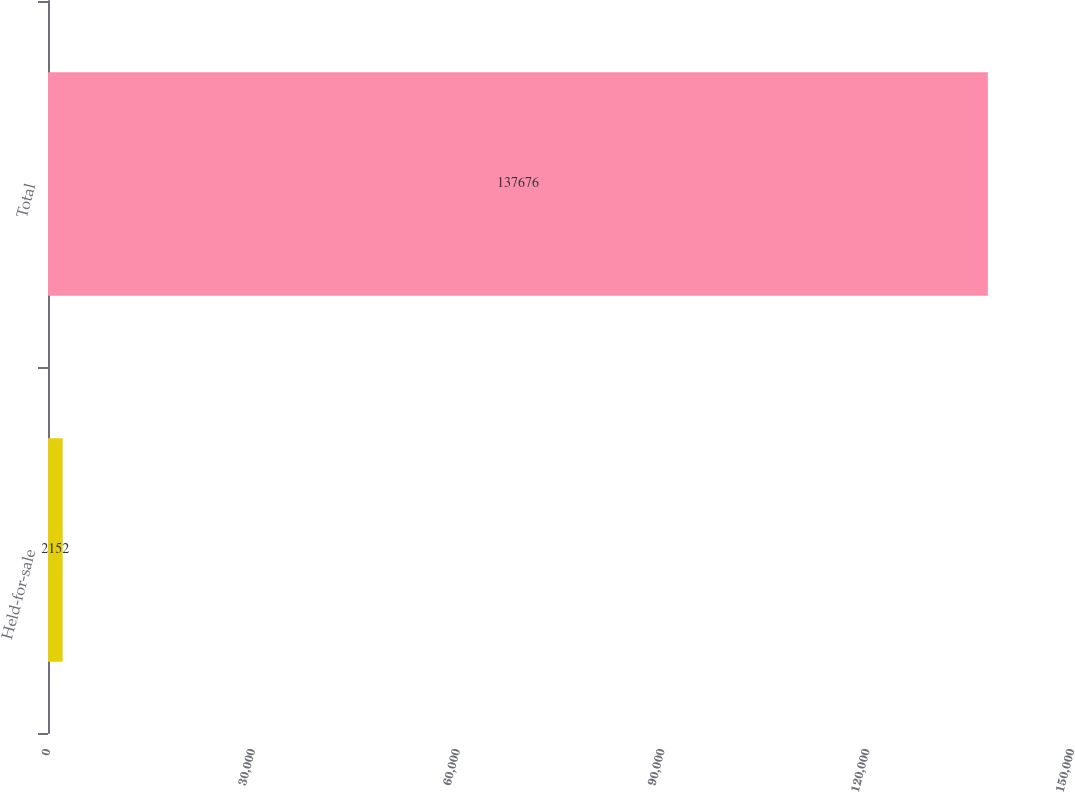Convert chart to OTSL. <chart><loc_0><loc_0><loc_500><loc_500><bar_chart><fcel>Held-for-sale<fcel>Total<nl><fcel>2152<fcel>137676<nl></chart> 